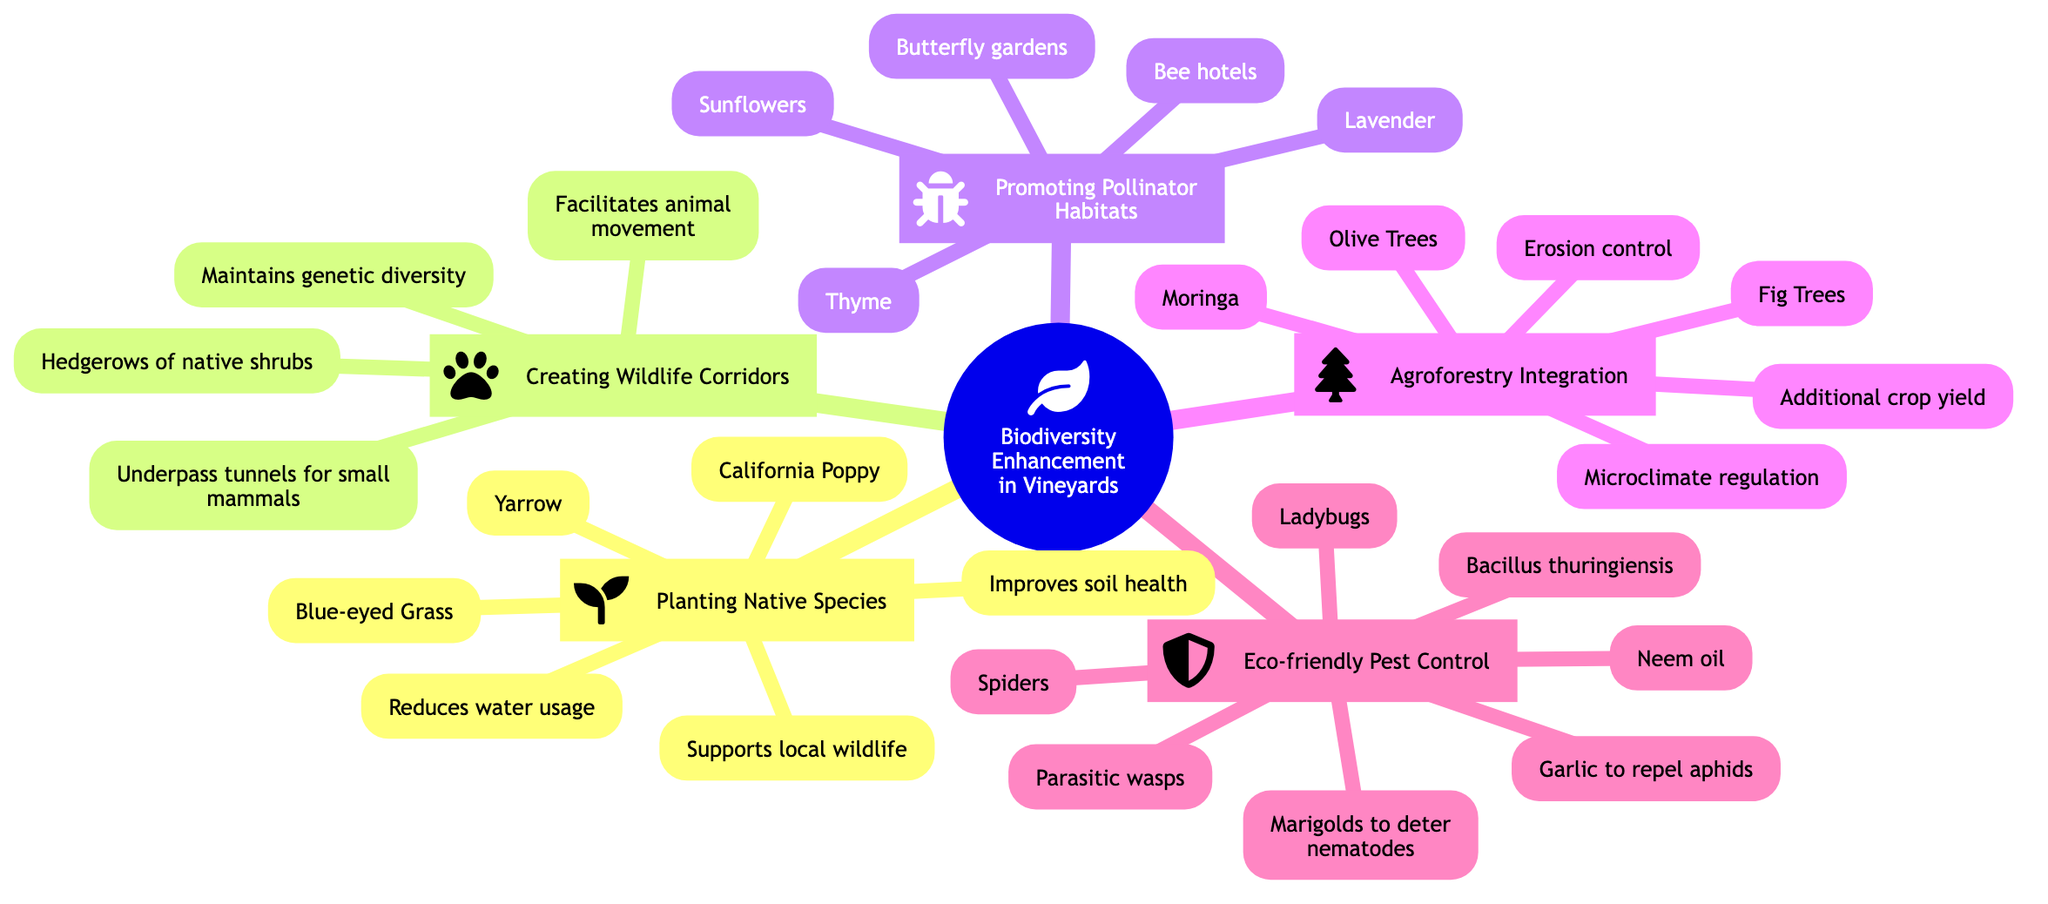What are the benefits of planting native species? The diagram states that the benefits of planting native species are: improves soil health, supports local wildlife, and reduces water usage. These are the three listed benefits under the "Planting Native Species" node.
Answer: Improves soil health, supports local wildlife, reduces water usage How many essential plants are listed for promoting pollinator habitats? Upon examining the "Promoting Pollinator Habitats" node, three essential plants are mentioned: Lavender, Thyme, and Sunflowers. Counting these gives us a total of three essential plants.
Answer: 3 What is the purpose of creating wildlife corridors? Looking at the "Creating Wildlife Corridors" node, there are two purposes provided: facilitates animal movement and maintains genetic diversity. Both purposes are directly listed under that node, making it clear what the intended goals are.
Answer: Facilitates animal movement, maintains genetic diversity Which pest can marigolds help to deter? The "Eco-friendly Pest Control" node includes companion planting strategies, and specifically mentions that marigolds are used to deter nematodes. This relation indicates their use in pest control.
Answer: Nematodes What agroforestry benefit relates to crop yield? Within the "Agroforestry Integration" node, one of the listed benefits is "Additional crop yield." This indicates how agroforestry practices can enhance overall agricultural output, particularly relevant to vineyards.
Answer: Additional crop yield How are bee hotels categorized in the context of pollinator habitats? In the "Promoting Pollinator Habitats" section, bee hotels are mentioned as one of the structures aimed at supporting pollinators. This categorizes them as part of the necessary infrastructure for enhancing pollinator habitats.
Answer: Structures Which natural predator is mentioned for eco-friendly pest control? Among the natural predators listed under the "Eco-friendly Pest Control" node, ladybugs are specifically mentioned as a beneficial insect that can help control pest populations.
Answer: Ladybugs What tree species is listed under agroforestry integration? The "Agroforestry Integration" node mentions three tree species, and one of them is Olive Trees. This indicates their role in sustainable farming practices and biodiversity enhancement in vineyards.
Answer: Olive Trees How many ways are identified for implementing wildlife corridors? The "Creating Wildlife Corridors" node lists two methods of implementation: hedgerows of native shrubs and underpass tunnels for small mammals. Counting these methods provides the total number identified for this practice.
Answer: 2 